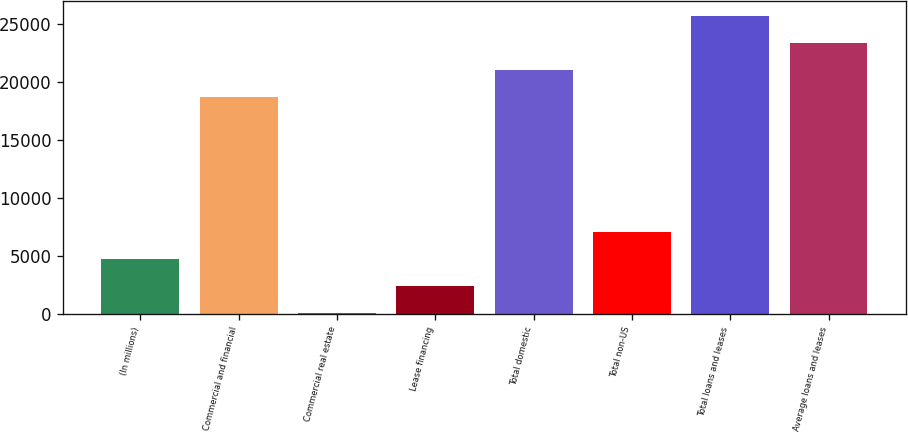Convert chart. <chart><loc_0><loc_0><loc_500><loc_500><bar_chart><fcel>(In millions)<fcel>Commercial and financial<fcel>Commercial real estate<fcel>Lease financing<fcel>Total domestic<fcel>Total non-US<fcel>Total loans and leases<fcel>Average loans and leases<nl><fcel>4737.2<fcel>18696<fcel>98<fcel>2417.6<fcel>21015.6<fcel>7056.8<fcel>25654.8<fcel>23335.2<nl></chart> 